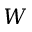Convert formula to latex. <formula><loc_0><loc_0><loc_500><loc_500>W</formula> 